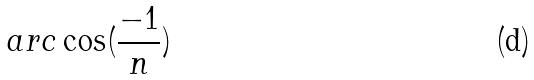<formula> <loc_0><loc_0><loc_500><loc_500>a r c \cos ( \frac { - 1 } { n } )</formula> 